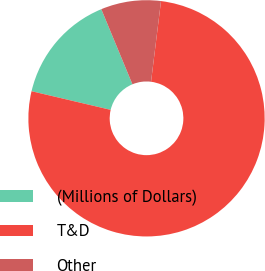<chart> <loc_0><loc_0><loc_500><loc_500><pie_chart><fcel>(Millions of Dollars)<fcel>T&D<fcel>Other<nl><fcel>15.06%<fcel>76.72%<fcel>8.21%<nl></chart> 